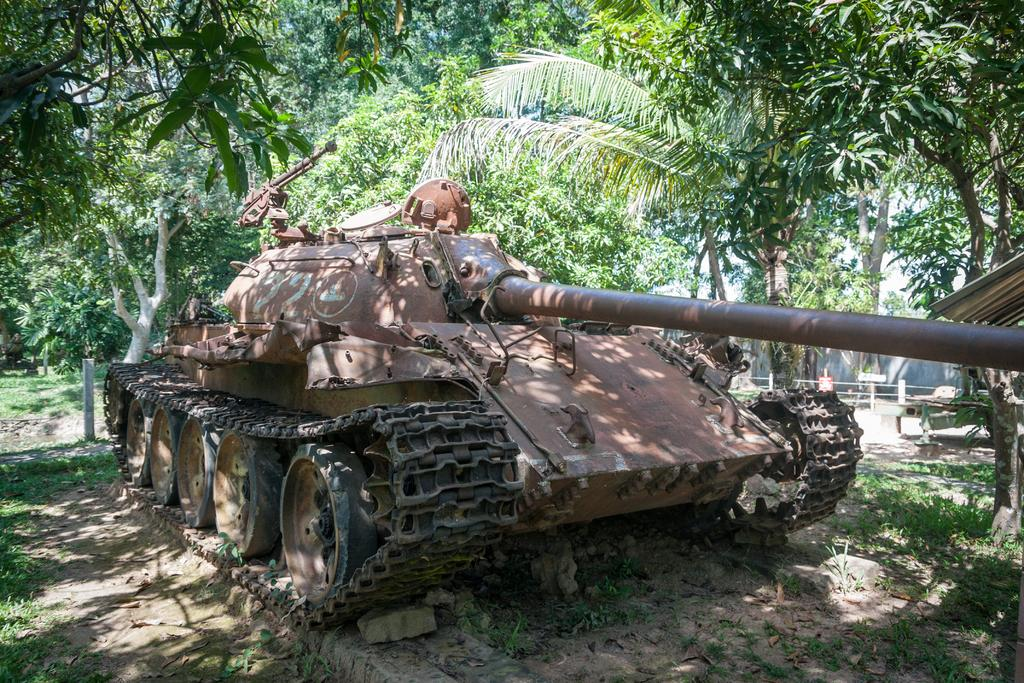What type of vehicle is in the image? There is a Churchill tank in the image. What can be seen in the background around the Churchill tank? There are trees and grass around the Churchill tank. What type of credit card is visible in the image? There is no credit card visible in the image; it features a Churchill tank surrounded by trees and grass. 